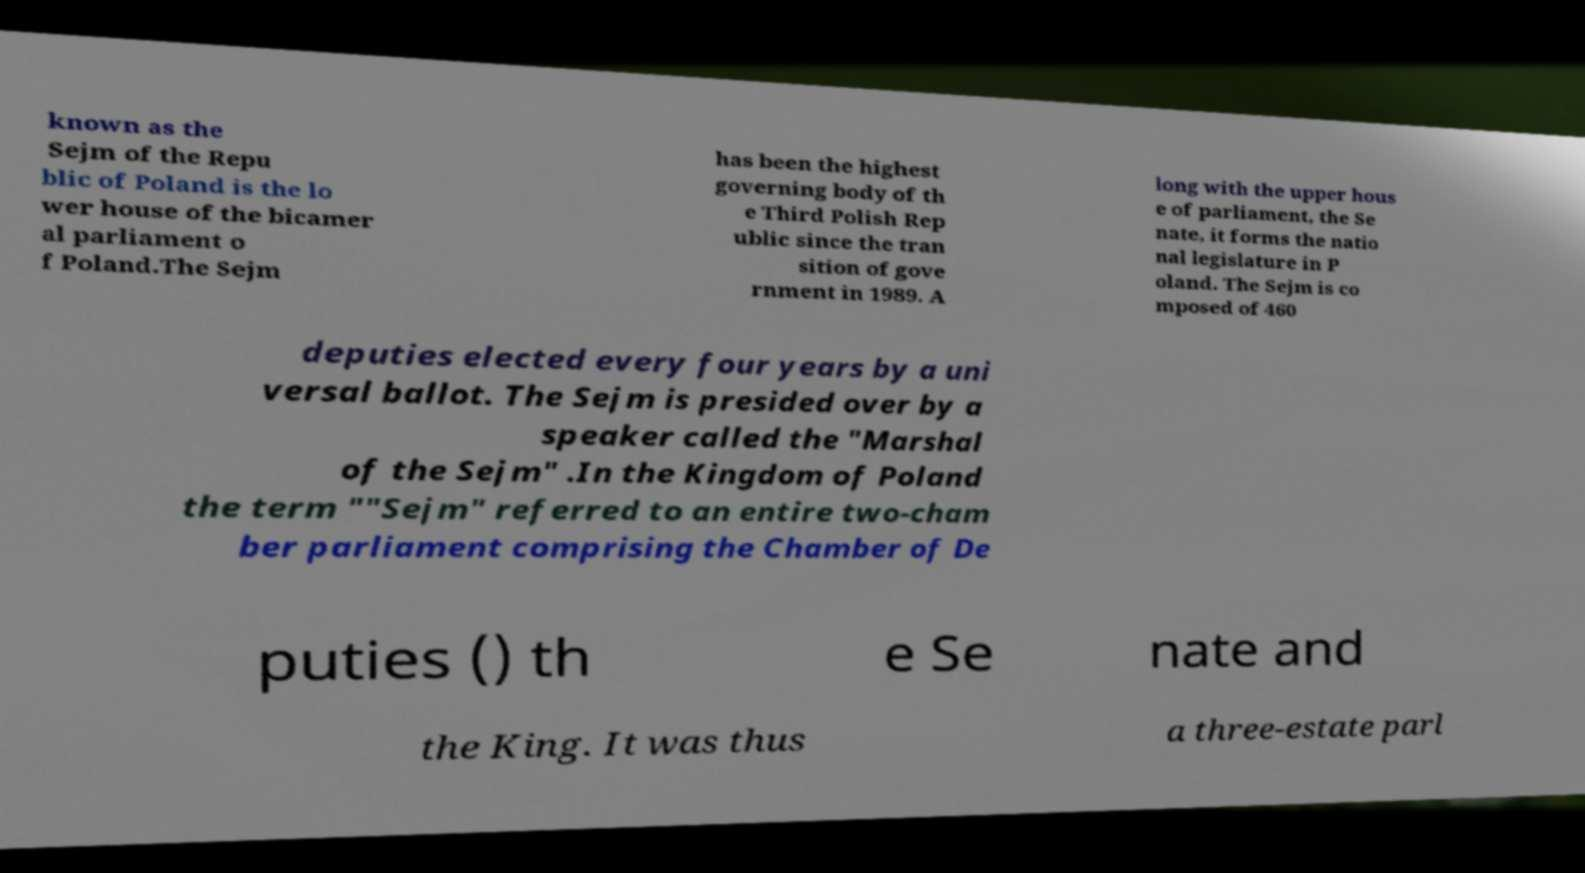What messages or text are displayed in this image? I need them in a readable, typed format. known as the Sejm of the Repu blic of Poland is the lo wer house of the bicamer al parliament o f Poland.The Sejm has been the highest governing body of th e Third Polish Rep ublic since the tran sition of gove rnment in 1989. A long with the upper hous e of parliament, the Se nate, it forms the natio nal legislature in P oland. The Sejm is co mposed of 460 deputies elected every four years by a uni versal ballot. The Sejm is presided over by a speaker called the "Marshal of the Sejm" .In the Kingdom of Poland the term ""Sejm" referred to an entire two-cham ber parliament comprising the Chamber of De puties () th e Se nate and the King. It was thus a three-estate parl 